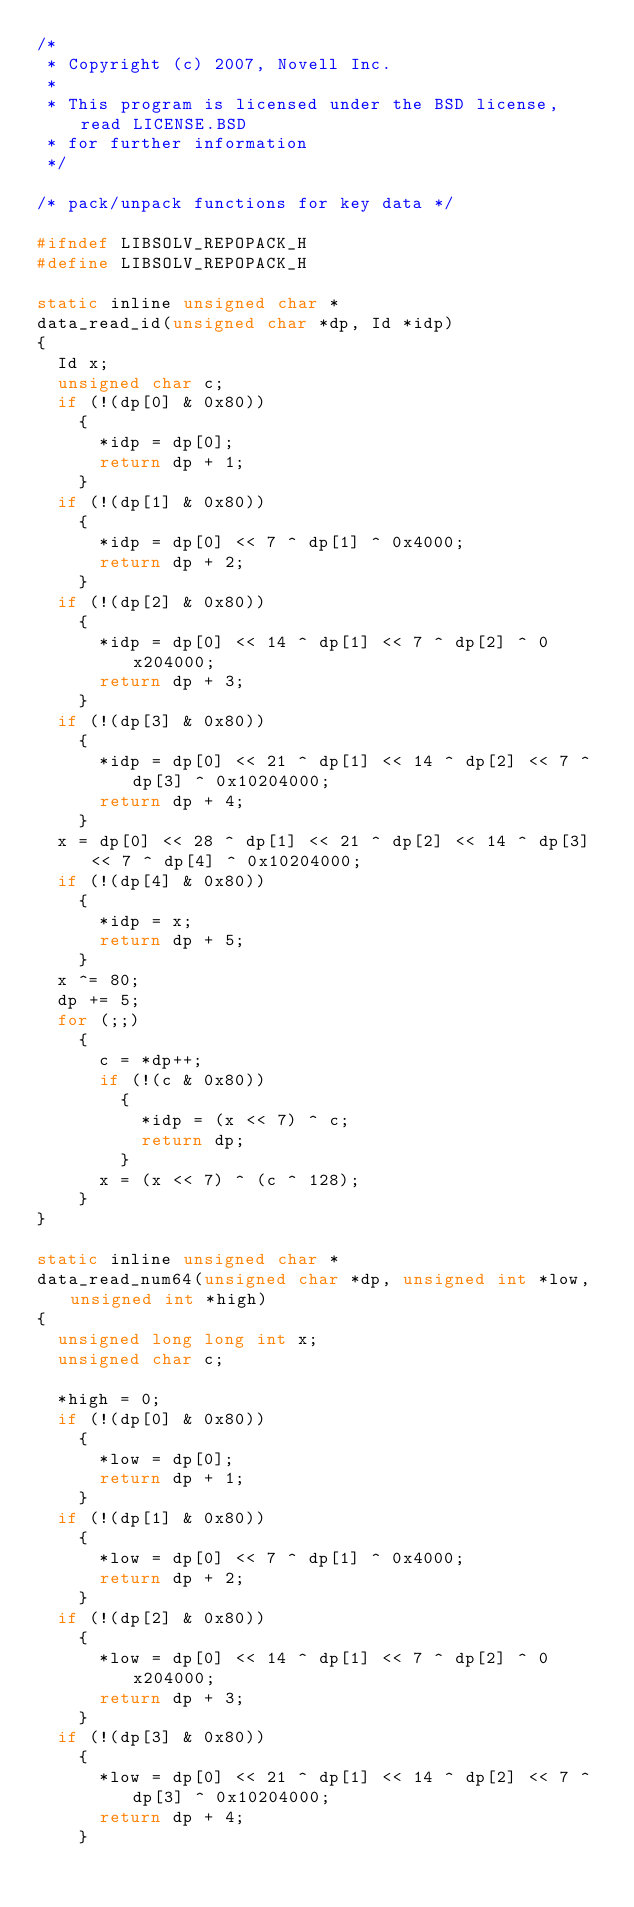<code> <loc_0><loc_0><loc_500><loc_500><_C_>/*
 * Copyright (c) 2007, Novell Inc.
 *
 * This program is licensed under the BSD license, read LICENSE.BSD
 * for further information
 */

/* pack/unpack functions for key data */

#ifndef LIBSOLV_REPOPACK_H
#define LIBSOLV_REPOPACK_H

static inline unsigned char *
data_read_id(unsigned char *dp, Id *idp)
{
  Id x;
  unsigned char c;
  if (!(dp[0] & 0x80))
    {
      *idp = dp[0];
      return dp + 1;
    }
  if (!(dp[1] & 0x80))
    {
      *idp = dp[0] << 7 ^ dp[1] ^ 0x4000;
      return dp + 2;
    }
  if (!(dp[2] & 0x80))
    {
      *idp = dp[0] << 14 ^ dp[1] << 7 ^ dp[2] ^ 0x204000;
      return dp + 3;
    }
  if (!(dp[3] & 0x80))
    {
      *idp = dp[0] << 21 ^ dp[1] << 14 ^ dp[2] << 7 ^ dp[3] ^ 0x10204000;
      return dp + 4;
    }
  x = dp[0] << 28 ^ dp[1] << 21 ^ dp[2] << 14 ^ dp[3] << 7 ^ dp[4] ^ 0x10204000;
  if (!(dp[4] & 0x80))
    {
      *idp = x;
      return dp + 5;
    }
  x ^= 80;
  dp += 5;
  for (;;)
    {
      c = *dp++;
      if (!(c & 0x80))
        {
          *idp = (x << 7) ^ c;
          return dp;
        }
      x = (x << 7) ^ (c ^ 128);
    }
}

static inline unsigned char *
data_read_num64(unsigned char *dp, unsigned int *low, unsigned int *high)
{
  unsigned long long int x;
  unsigned char c;

  *high = 0;
  if (!(dp[0] & 0x80))
    {
      *low = dp[0];
      return dp + 1;
    }
  if (!(dp[1] & 0x80))
    {
      *low = dp[0] << 7 ^ dp[1] ^ 0x4000;
      return dp + 2;
    }
  if (!(dp[2] & 0x80))
    {
      *low = dp[0] << 14 ^ dp[1] << 7 ^ dp[2] ^ 0x204000;
      return dp + 3;
    }
  if (!(dp[3] & 0x80))
    {
      *low = dp[0] << 21 ^ dp[1] << 14 ^ dp[2] << 7 ^ dp[3] ^ 0x10204000;
      return dp + 4;
    }</code> 